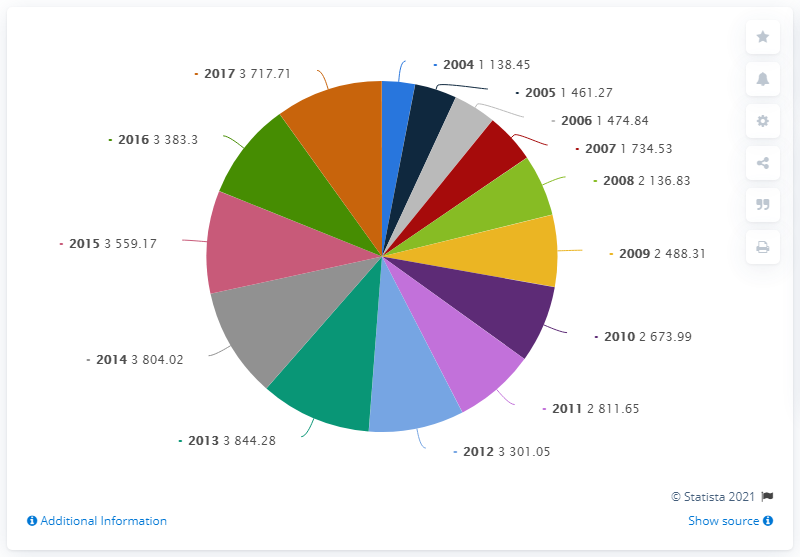Outline some significant characteristics in this image. The investment was first tripled nine years later from 2004. In 2013, a total of $3804.02 was invested in road transport infrastructure. In 2016, a total of NOK 3717.71 was invested in road infrastructure in Norway. There are 14 data points represented by the pie chart. 